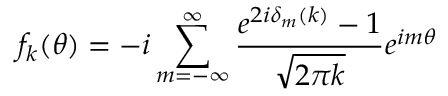<formula> <loc_0><loc_0><loc_500><loc_500>f _ { k } ( \theta ) = - i \sum _ { m = - \infty } ^ { \infty } { \frac { e ^ { 2 i \delta _ { m } ( k ) } - 1 } { \sqrt { 2 \pi k } } } e ^ { i m \theta } \,</formula> 